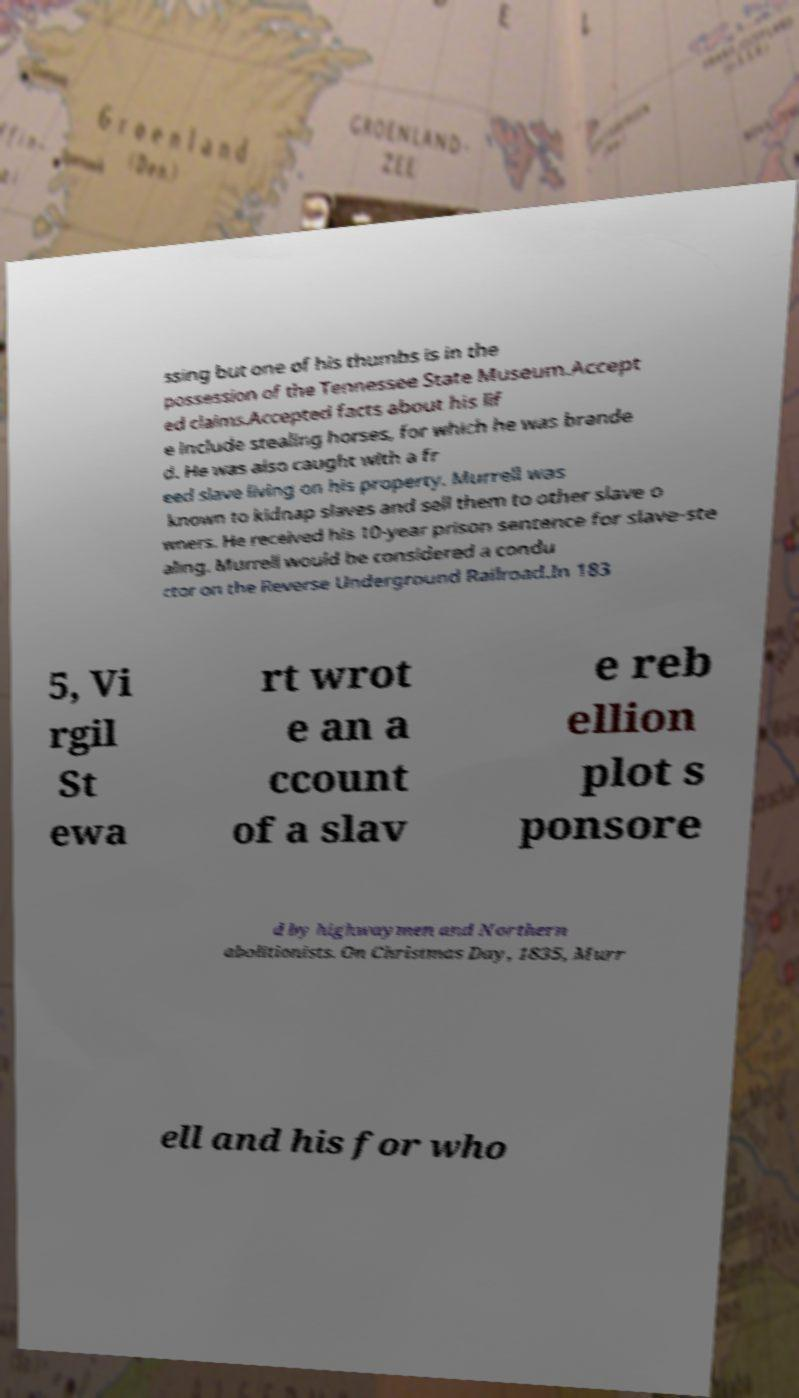Could you assist in decoding the text presented in this image and type it out clearly? ssing but one of his thumbs is in the possession of the Tennessee State Museum.Accept ed claims.Accepted facts about his lif e include stealing horses, for which he was brande d. He was also caught with a fr eed slave living on his property. Murrell was known to kidnap slaves and sell them to other slave o wners. He received his 10-year prison sentence for slave-ste aling. Murrell would be considered a condu ctor on the Reverse Underground Railroad.In 183 5, Vi rgil St ewa rt wrot e an a ccount of a slav e reb ellion plot s ponsore d by highwaymen and Northern abolitionists. On Christmas Day, 1835, Murr ell and his for who 